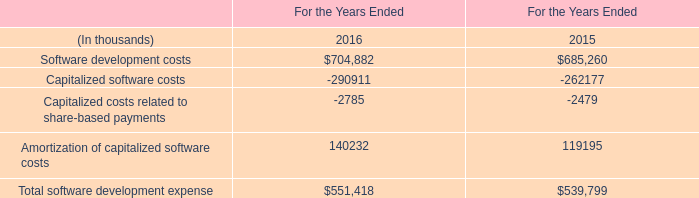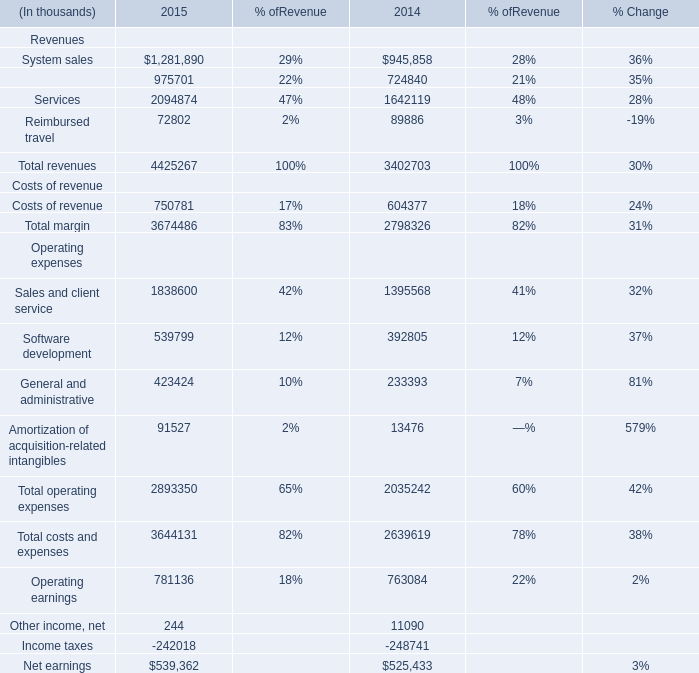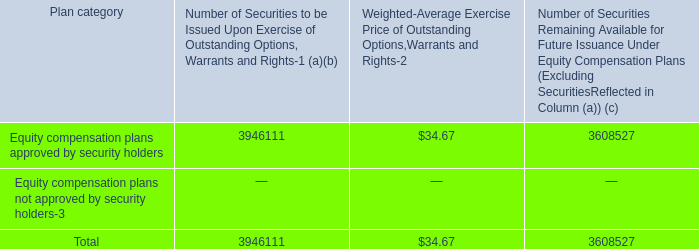What is the sum of Software development costs of For the Years Ended 2016, Software development Operating expenses of 2015, and Software development Operating expenses of 2014 ? 
Computations: ((704882.0 + 539799.0) + 392805.0)
Answer: 1637486.0. 